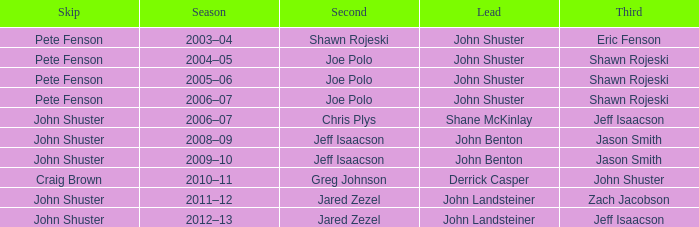Who was second when Shane McKinlay was the lead? Chris Plys. 